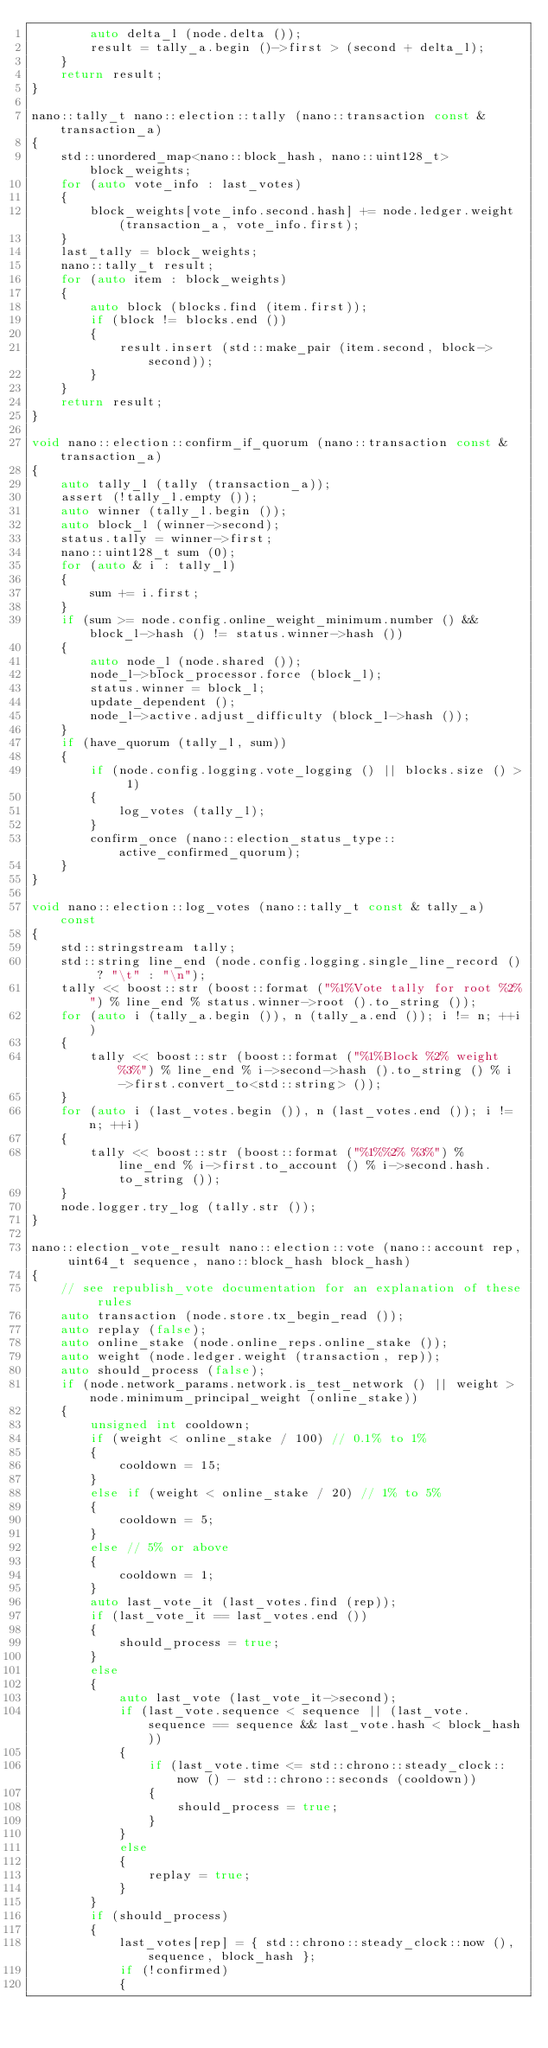Convert code to text. <code><loc_0><loc_0><loc_500><loc_500><_C++_>		auto delta_l (node.delta ());
		result = tally_a.begin ()->first > (second + delta_l);
	}
	return result;
}

nano::tally_t nano::election::tally (nano::transaction const & transaction_a)
{
	std::unordered_map<nano::block_hash, nano::uint128_t> block_weights;
	for (auto vote_info : last_votes)
	{
		block_weights[vote_info.second.hash] += node.ledger.weight (transaction_a, vote_info.first);
	}
	last_tally = block_weights;
	nano::tally_t result;
	for (auto item : block_weights)
	{
		auto block (blocks.find (item.first));
		if (block != blocks.end ())
		{
			result.insert (std::make_pair (item.second, block->second));
		}
	}
	return result;
}

void nano::election::confirm_if_quorum (nano::transaction const & transaction_a)
{
	auto tally_l (tally (transaction_a));
	assert (!tally_l.empty ());
	auto winner (tally_l.begin ());
	auto block_l (winner->second);
	status.tally = winner->first;
	nano::uint128_t sum (0);
	for (auto & i : tally_l)
	{
		sum += i.first;
	}
	if (sum >= node.config.online_weight_minimum.number () && block_l->hash () != status.winner->hash ())
	{
		auto node_l (node.shared ());
		node_l->block_processor.force (block_l);
		status.winner = block_l;
		update_dependent ();
		node_l->active.adjust_difficulty (block_l->hash ());
	}
	if (have_quorum (tally_l, sum))
	{
		if (node.config.logging.vote_logging () || blocks.size () > 1)
		{
			log_votes (tally_l);
		}
		confirm_once (nano::election_status_type::active_confirmed_quorum);
	}
}

void nano::election::log_votes (nano::tally_t const & tally_a) const
{
	std::stringstream tally;
	std::string line_end (node.config.logging.single_line_record () ? "\t" : "\n");
	tally << boost::str (boost::format ("%1%Vote tally for root %2%") % line_end % status.winner->root ().to_string ());
	for (auto i (tally_a.begin ()), n (tally_a.end ()); i != n; ++i)
	{
		tally << boost::str (boost::format ("%1%Block %2% weight %3%") % line_end % i->second->hash ().to_string () % i->first.convert_to<std::string> ());
	}
	for (auto i (last_votes.begin ()), n (last_votes.end ()); i != n; ++i)
	{
		tally << boost::str (boost::format ("%1%%2% %3%") % line_end % i->first.to_account () % i->second.hash.to_string ());
	}
	node.logger.try_log (tally.str ());
}

nano::election_vote_result nano::election::vote (nano::account rep, uint64_t sequence, nano::block_hash block_hash)
{
	// see republish_vote documentation for an explanation of these rules
	auto transaction (node.store.tx_begin_read ());
	auto replay (false);
	auto online_stake (node.online_reps.online_stake ());
	auto weight (node.ledger.weight (transaction, rep));
	auto should_process (false);
	if (node.network_params.network.is_test_network () || weight > node.minimum_principal_weight (online_stake))
	{
		unsigned int cooldown;
		if (weight < online_stake / 100) // 0.1% to 1%
		{
			cooldown = 15;
		}
		else if (weight < online_stake / 20) // 1% to 5%
		{
			cooldown = 5;
		}
		else // 5% or above
		{
			cooldown = 1;
		}
		auto last_vote_it (last_votes.find (rep));
		if (last_vote_it == last_votes.end ())
		{
			should_process = true;
		}
		else
		{
			auto last_vote (last_vote_it->second);
			if (last_vote.sequence < sequence || (last_vote.sequence == sequence && last_vote.hash < block_hash))
			{
				if (last_vote.time <= std::chrono::steady_clock::now () - std::chrono::seconds (cooldown))
				{
					should_process = true;
				}
			}
			else
			{
				replay = true;
			}
		}
		if (should_process)
		{
			last_votes[rep] = { std::chrono::steady_clock::now (), sequence, block_hash };
			if (!confirmed)
			{</code> 